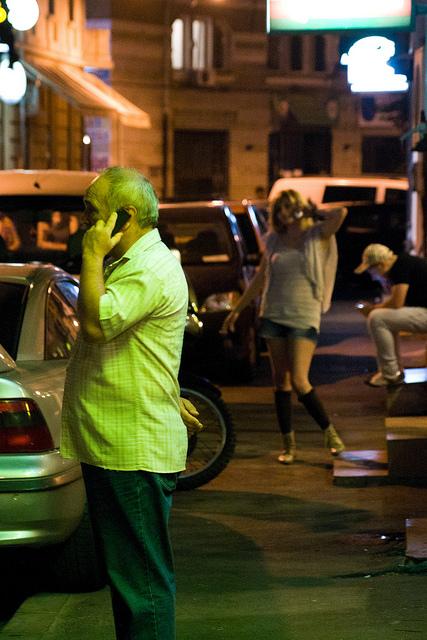Is it at night?
Quick response, please. Yes. Is the man on a cellphone or a landline?
Write a very short answer. Cell phone. Is there neon lights in the image?
Short answer required. Yes. 